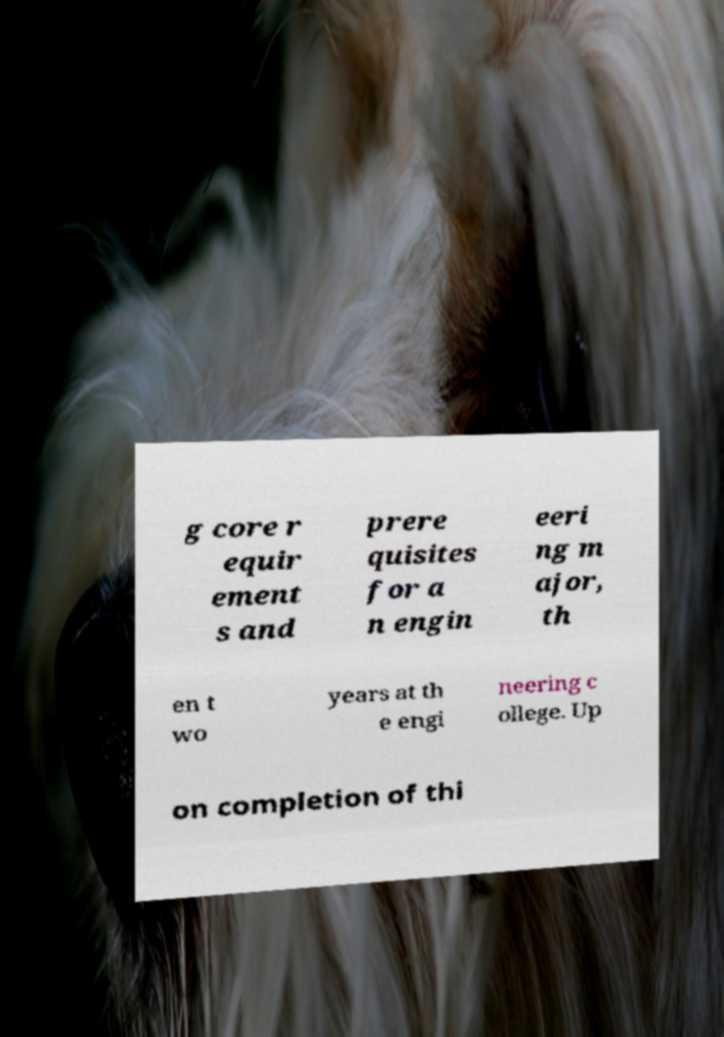Can you accurately transcribe the text from the provided image for me? g core r equir ement s and prere quisites for a n engin eeri ng m ajor, th en t wo years at th e engi neering c ollege. Up on completion of thi 